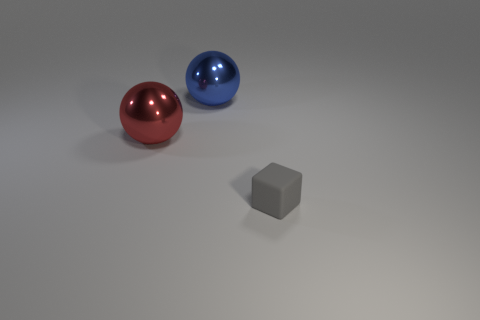Subtract all blue balls. How many balls are left? 1 Add 1 shiny spheres. How many objects exist? 4 Subtract all balls. How many objects are left? 1 Subtract 1 balls. How many balls are left? 1 Add 1 tiny gray objects. How many tiny gray objects exist? 2 Subtract 0 cyan balls. How many objects are left? 3 Subtract all yellow balls. Subtract all red cylinders. How many balls are left? 2 Subtract all large red metallic balls. Subtract all big blue shiny balls. How many objects are left? 1 Add 2 large spheres. How many large spheres are left? 4 